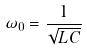Convert formula to latex. <formula><loc_0><loc_0><loc_500><loc_500>\omega _ { 0 } = \frac { 1 } { \sqrt { L C } }</formula> 